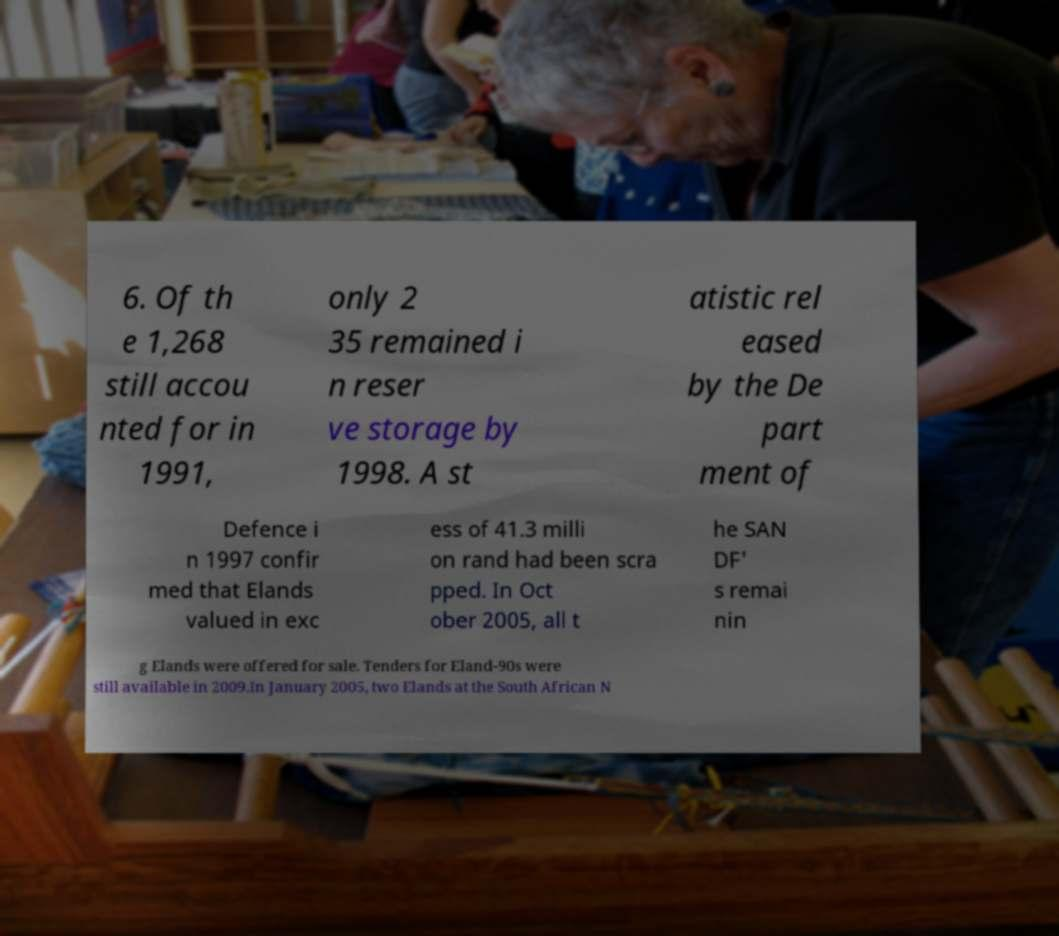Please read and relay the text visible in this image. What does it say? 6. Of th e 1,268 still accou nted for in 1991, only 2 35 remained i n reser ve storage by 1998. A st atistic rel eased by the De part ment of Defence i n 1997 confir med that Elands valued in exc ess of 41.3 milli on rand had been scra pped. In Oct ober 2005, all t he SAN DF' s remai nin g Elands were offered for sale. Tenders for Eland-90s were still available in 2009.In January 2005, two Elands at the South African N 